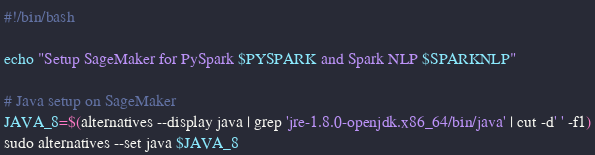<code> <loc_0><loc_0><loc_500><loc_500><_Bash_>#!/bin/bash

echo "Setup SageMaker for PySpark $PYSPARK and Spark NLP $SPARKNLP"

# Java setup on SageMaker
JAVA_8=$(alternatives --display java | grep 'jre-1.8.0-openjdk.x86_64/bin/java' | cut -d' ' -f1)
sudo alternatives --set java $JAVA_8
</code> 